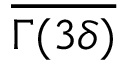<formula> <loc_0><loc_0><loc_500><loc_500>\overline { \Gamma ( 3 \delta ) }</formula> 